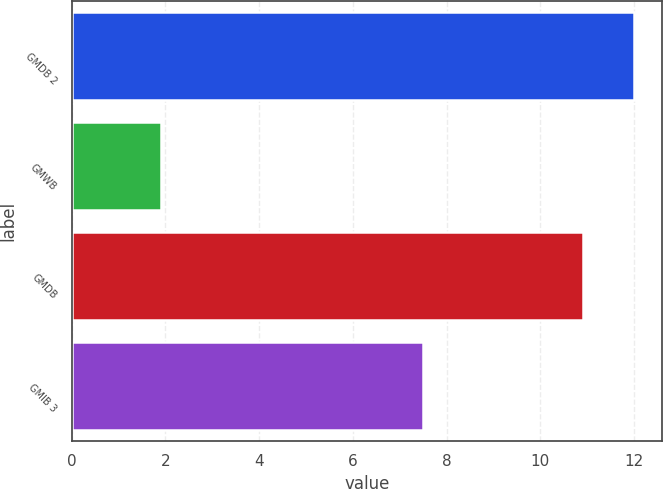<chart> <loc_0><loc_0><loc_500><loc_500><bar_chart><fcel>GMDB 2<fcel>GMWB<fcel>GMDB<fcel>GMIB 3<nl><fcel>12<fcel>1.9<fcel>10.9<fcel>7.5<nl></chart> 